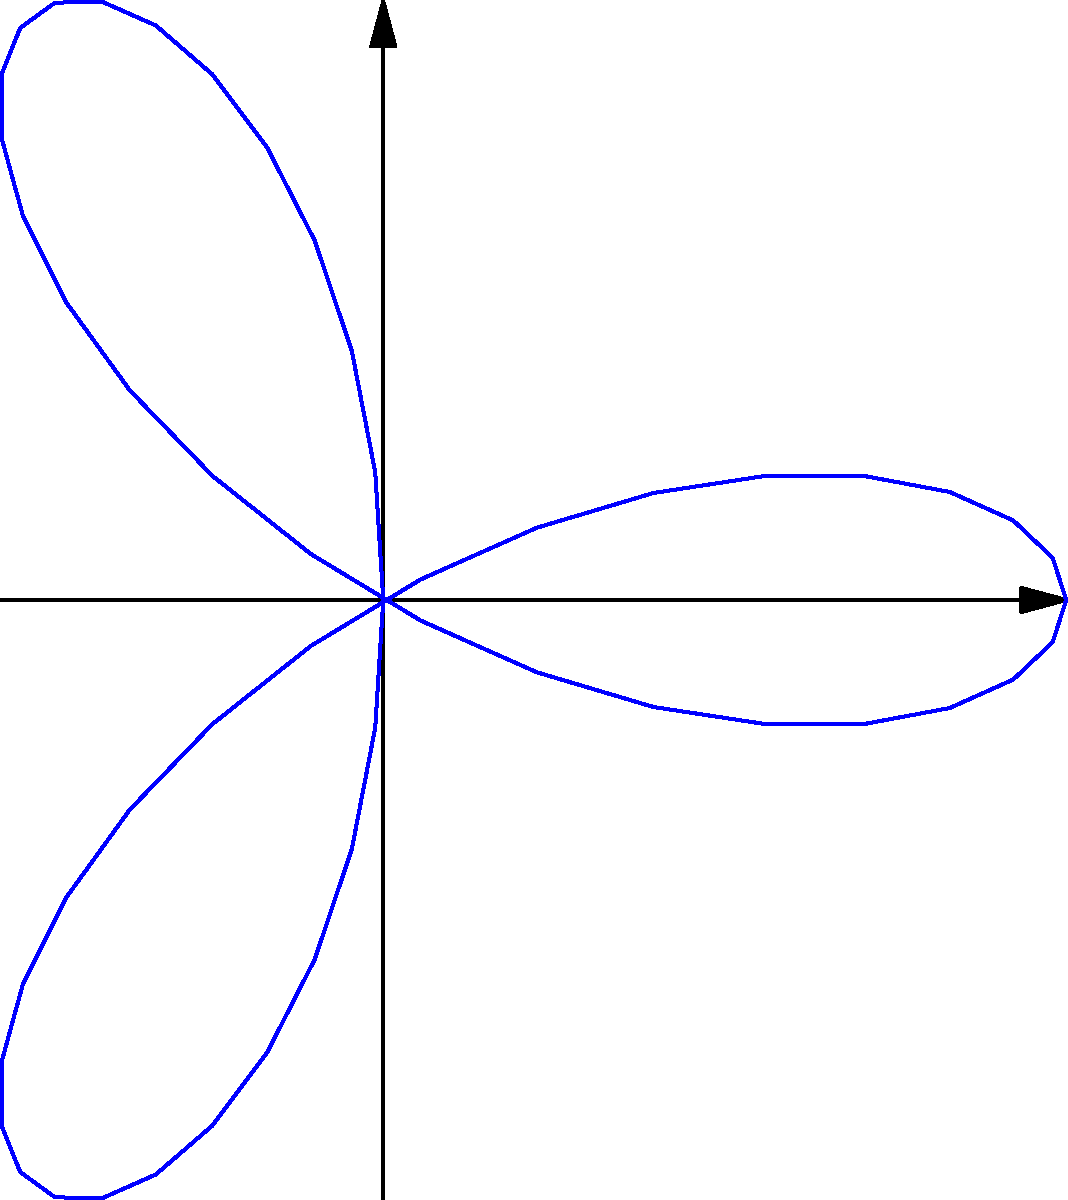As a parent excited to challenge your children's mathematical skills, you come across a fascinating polar rose curve. The curve is defined by the equation $r = 2\cos(3\theta)$. What is the area enclosed by this curve? Let's approach this step-by-step:

1) The general formula for the area enclosed by a polar curve is:
   $$A = \frac{1}{2} \int_0^{2\pi} r^2(\theta) d\theta$$

2) In our case, $r = 2\cos(3\theta)$, so $r^2 = 4\cos^2(3\theta)$

3) Substituting this into our formula:
   $$A = \frac{1}{2} \int_0^{2\pi} 4\cos^2(3\theta) d\theta$$

4) We can simplify this using the trigonometric identity:
   $$\cos^2(x) = \frac{1 + \cos(2x)}{2}$$

5) Applying this to our integral:
   $$A = \frac{1}{2} \int_0^{2\pi} 4 \cdot \frac{1 + \cos(6\theta)}{2} d\theta$$
   $$A = \int_0^{2\pi} (1 + \cos(6\theta)) d\theta$$

6) Now we can integrate:
   $$A = [\theta + \frac{1}{6}\sin(6\theta)]_0^{2\pi}$$

7) Evaluating at the limits:
   $$A = (2\pi + 0) - (0 + 0) = 2\pi$$

Therefore, the area enclosed by the curve is $2\pi$ square units.
Answer: $2\pi$ square units 